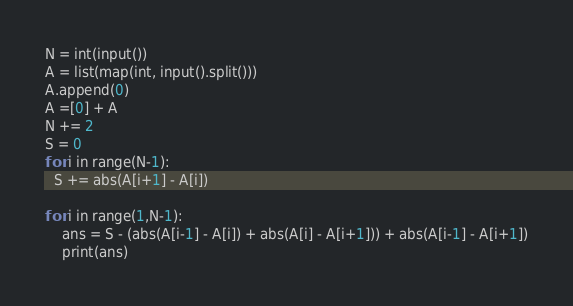<code> <loc_0><loc_0><loc_500><loc_500><_Python_>N = int(input())
A = list(map(int, input().split()))
A.append(0)
A =[0] + A
N += 2
S = 0
for i in range(N-1):
  S += abs(A[i+1] - A[i]) 

for i in range(1,N-1):
    ans = S - (abs(A[i-1] - A[i]) + abs(A[i] - A[i+1])) + abs(A[i-1] - A[i+1])
    print(ans)</code> 